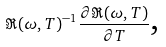Convert formula to latex. <formula><loc_0><loc_0><loc_500><loc_500>\Re ( \omega , T ) ^ { - 1 } \frac { \partial \Re ( \omega , T ) } { \partial T } \text {,}</formula> 